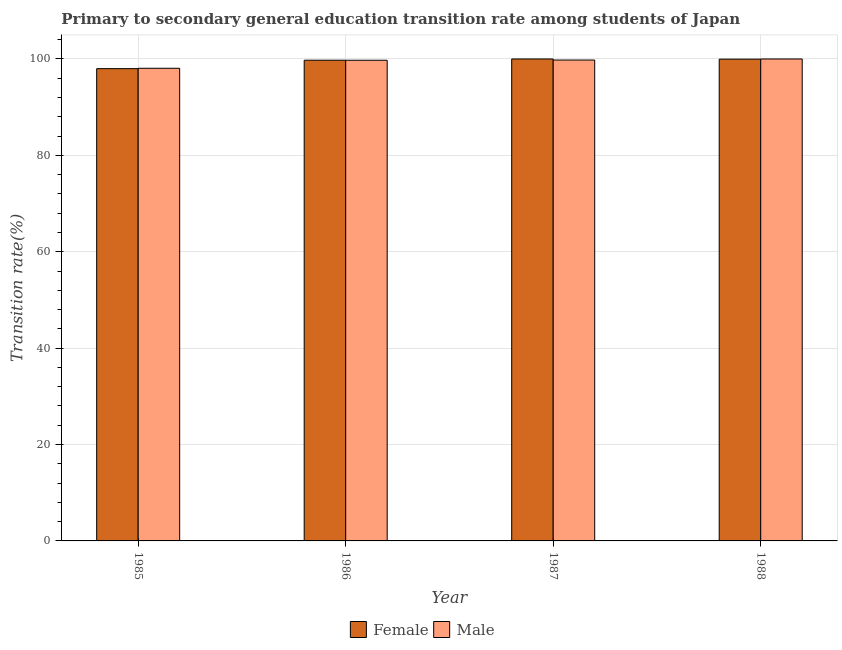How many different coloured bars are there?
Offer a very short reply. 2. How many groups of bars are there?
Offer a terse response. 4. Are the number of bars per tick equal to the number of legend labels?
Your response must be concise. Yes. How many bars are there on the 3rd tick from the right?
Offer a very short reply. 2. In how many cases, is the number of bars for a given year not equal to the number of legend labels?
Your response must be concise. 0. What is the transition rate among male students in 1986?
Make the answer very short. 99.73. Across all years, what is the minimum transition rate among female students?
Your response must be concise. 97.99. In which year was the transition rate among female students maximum?
Make the answer very short. 1987. In which year was the transition rate among female students minimum?
Your answer should be very brief. 1985. What is the total transition rate among female students in the graph?
Provide a succinct answer. 397.7. What is the difference between the transition rate among female students in 1985 and that in 1988?
Your answer should be compact. -1.97. What is the difference between the transition rate among male students in 1986 and the transition rate among female students in 1985?
Provide a short and direct response. 1.66. What is the average transition rate among female students per year?
Provide a short and direct response. 99.42. In the year 1987, what is the difference between the transition rate among male students and transition rate among female students?
Keep it short and to the point. 0. In how many years, is the transition rate among male students greater than 32 %?
Your answer should be very brief. 4. What is the ratio of the transition rate among male students in 1985 to that in 1987?
Your answer should be very brief. 0.98. Is the difference between the transition rate among male students in 1985 and 1988 greater than the difference between the transition rate among female students in 1985 and 1988?
Keep it short and to the point. No. What is the difference between the highest and the second highest transition rate among female students?
Give a very brief answer. 0.04. What is the difference between the highest and the lowest transition rate among female students?
Your response must be concise. 2.01. In how many years, is the transition rate among male students greater than the average transition rate among male students taken over all years?
Make the answer very short. 3. What does the 2nd bar from the left in 1988 represents?
Give a very brief answer. Male. What does the 2nd bar from the right in 1988 represents?
Offer a very short reply. Female. Are all the bars in the graph horizontal?
Your response must be concise. No. How many years are there in the graph?
Your answer should be very brief. 4. What is the difference between two consecutive major ticks on the Y-axis?
Offer a very short reply. 20. Are the values on the major ticks of Y-axis written in scientific E-notation?
Provide a short and direct response. No. Does the graph contain any zero values?
Your response must be concise. No. How are the legend labels stacked?
Offer a very short reply. Horizontal. What is the title of the graph?
Give a very brief answer. Primary to secondary general education transition rate among students of Japan. Does "Old" appear as one of the legend labels in the graph?
Offer a terse response. No. What is the label or title of the X-axis?
Your answer should be compact. Year. What is the label or title of the Y-axis?
Your response must be concise. Transition rate(%). What is the Transition rate(%) in Female in 1985?
Offer a very short reply. 97.99. What is the Transition rate(%) of Male in 1985?
Your answer should be very brief. 98.07. What is the Transition rate(%) in Female in 1986?
Offer a very short reply. 99.74. What is the Transition rate(%) in Male in 1986?
Your answer should be compact. 99.73. What is the Transition rate(%) of Male in 1987?
Your answer should be very brief. 99.78. What is the Transition rate(%) of Female in 1988?
Provide a succinct answer. 99.96. What is the Transition rate(%) in Male in 1988?
Provide a short and direct response. 100. Across all years, what is the maximum Transition rate(%) in Female?
Your answer should be very brief. 100. Across all years, what is the maximum Transition rate(%) in Male?
Make the answer very short. 100. Across all years, what is the minimum Transition rate(%) of Female?
Offer a very short reply. 97.99. Across all years, what is the minimum Transition rate(%) of Male?
Make the answer very short. 98.07. What is the total Transition rate(%) in Female in the graph?
Provide a succinct answer. 397.7. What is the total Transition rate(%) of Male in the graph?
Provide a succinct answer. 397.58. What is the difference between the Transition rate(%) in Female in 1985 and that in 1986?
Give a very brief answer. -1.75. What is the difference between the Transition rate(%) in Male in 1985 and that in 1986?
Offer a very short reply. -1.66. What is the difference between the Transition rate(%) in Female in 1985 and that in 1987?
Give a very brief answer. -2.01. What is the difference between the Transition rate(%) in Male in 1985 and that in 1987?
Your response must be concise. -1.71. What is the difference between the Transition rate(%) of Female in 1985 and that in 1988?
Provide a succinct answer. -1.97. What is the difference between the Transition rate(%) of Male in 1985 and that in 1988?
Keep it short and to the point. -1.93. What is the difference between the Transition rate(%) in Female in 1986 and that in 1987?
Provide a succinct answer. -0.26. What is the difference between the Transition rate(%) in Male in 1986 and that in 1987?
Give a very brief answer. -0.04. What is the difference between the Transition rate(%) of Female in 1986 and that in 1988?
Provide a short and direct response. -0.22. What is the difference between the Transition rate(%) of Male in 1986 and that in 1988?
Keep it short and to the point. -0.27. What is the difference between the Transition rate(%) in Female in 1987 and that in 1988?
Your answer should be compact. 0.04. What is the difference between the Transition rate(%) in Male in 1987 and that in 1988?
Make the answer very short. -0.22. What is the difference between the Transition rate(%) of Female in 1985 and the Transition rate(%) of Male in 1986?
Offer a very short reply. -1.74. What is the difference between the Transition rate(%) in Female in 1985 and the Transition rate(%) in Male in 1987?
Your answer should be very brief. -1.78. What is the difference between the Transition rate(%) of Female in 1985 and the Transition rate(%) of Male in 1988?
Keep it short and to the point. -2.01. What is the difference between the Transition rate(%) of Female in 1986 and the Transition rate(%) of Male in 1987?
Offer a terse response. -0.04. What is the difference between the Transition rate(%) in Female in 1986 and the Transition rate(%) in Male in 1988?
Give a very brief answer. -0.26. What is the difference between the Transition rate(%) of Female in 1987 and the Transition rate(%) of Male in 1988?
Your answer should be compact. 0. What is the average Transition rate(%) of Female per year?
Give a very brief answer. 99.42. What is the average Transition rate(%) of Male per year?
Your answer should be very brief. 99.4. In the year 1985, what is the difference between the Transition rate(%) in Female and Transition rate(%) in Male?
Offer a terse response. -0.08. In the year 1986, what is the difference between the Transition rate(%) of Female and Transition rate(%) of Male?
Offer a terse response. 0.01. In the year 1987, what is the difference between the Transition rate(%) of Female and Transition rate(%) of Male?
Provide a succinct answer. 0.22. In the year 1988, what is the difference between the Transition rate(%) of Female and Transition rate(%) of Male?
Offer a very short reply. -0.04. What is the ratio of the Transition rate(%) in Female in 1985 to that in 1986?
Make the answer very short. 0.98. What is the ratio of the Transition rate(%) in Male in 1985 to that in 1986?
Keep it short and to the point. 0.98. What is the ratio of the Transition rate(%) in Female in 1985 to that in 1987?
Give a very brief answer. 0.98. What is the ratio of the Transition rate(%) in Male in 1985 to that in 1987?
Your response must be concise. 0.98. What is the ratio of the Transition rate(%) of Female in 1985 to that in 1988?
Provide a succinct answer. 0.98. What is the ratio of the Transition rate(%) in Male in 1985 to that in 1988?
Your response must be concise. 0.98. What is the ratio of the Transition rate(%) in Female in 1986 to that in 1987?
Your answer should be compact. 1. What is the ratio of the Transition rate(%) in Male in 1986 to that in 1987?
Provide a short and direct response. 1. What is the ratio of the Transition rate(%) of Female in 1987 to that in 1988?
Offer a terse response. 1. What is the ratio of the Transition rate(%) of Male in 1987 to that in 1988?
Provide a succinct answer. 1. What is the difference between the highest and the second highest Transition rate(%) in Female?
Your answer should be compact. 0.04. What is the difference between the highest and the second highest Transition rate(%) in Male?
Your answer should be very brief. 0.22. What is the difference between the highest and the lowest Transition rate(%) of Female?
Offer a very short reply. 2.01. What is the difference between the highest and the lowest Transition rate(%) of Male?
Give a very brief answer. 1.93. 